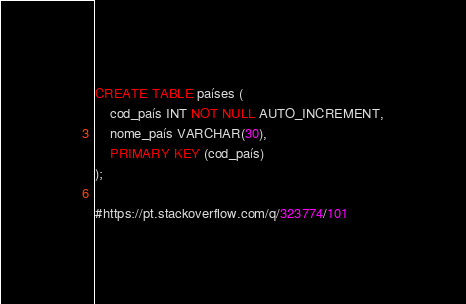<code> <loc_0><loc_0><loc_500><loc_500><_SQL_>CREATE TABLE países (
    cod_país INT NOT NULL AUTO_INCREMENT,
    nome_país VARCHAR(30),
    PRIMARY KEY (cod_país)
);

#https://pt.stackoverflow.com/q/323774/101
</code> 